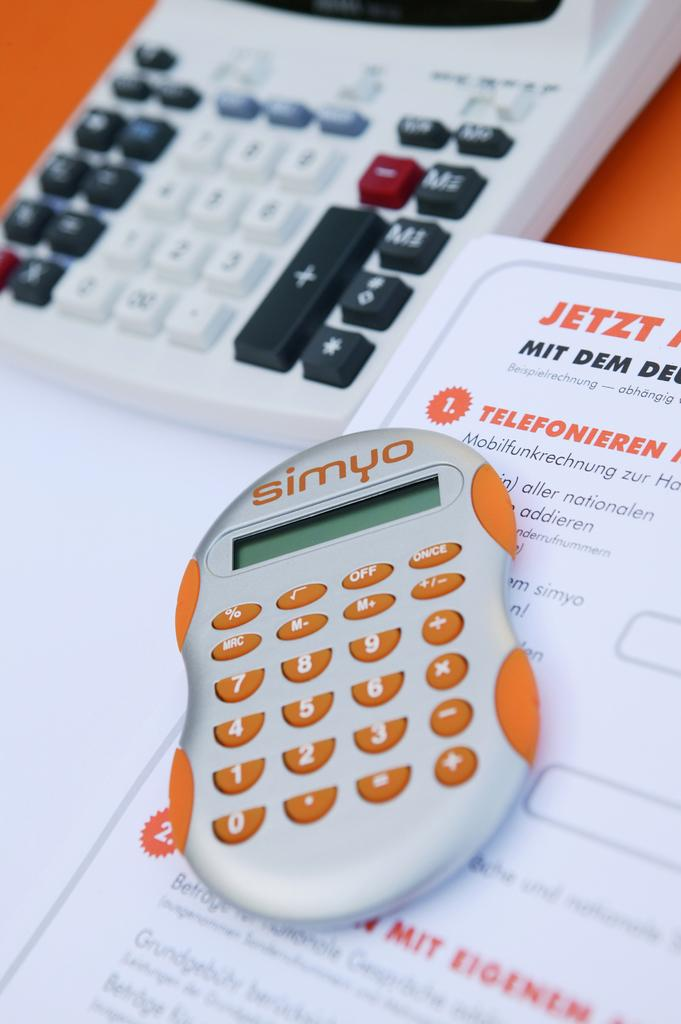<image>
Write a terse but informative summary of the picture. A Simyo calculator in front of German words like "Jetzt" and a larger calculator 